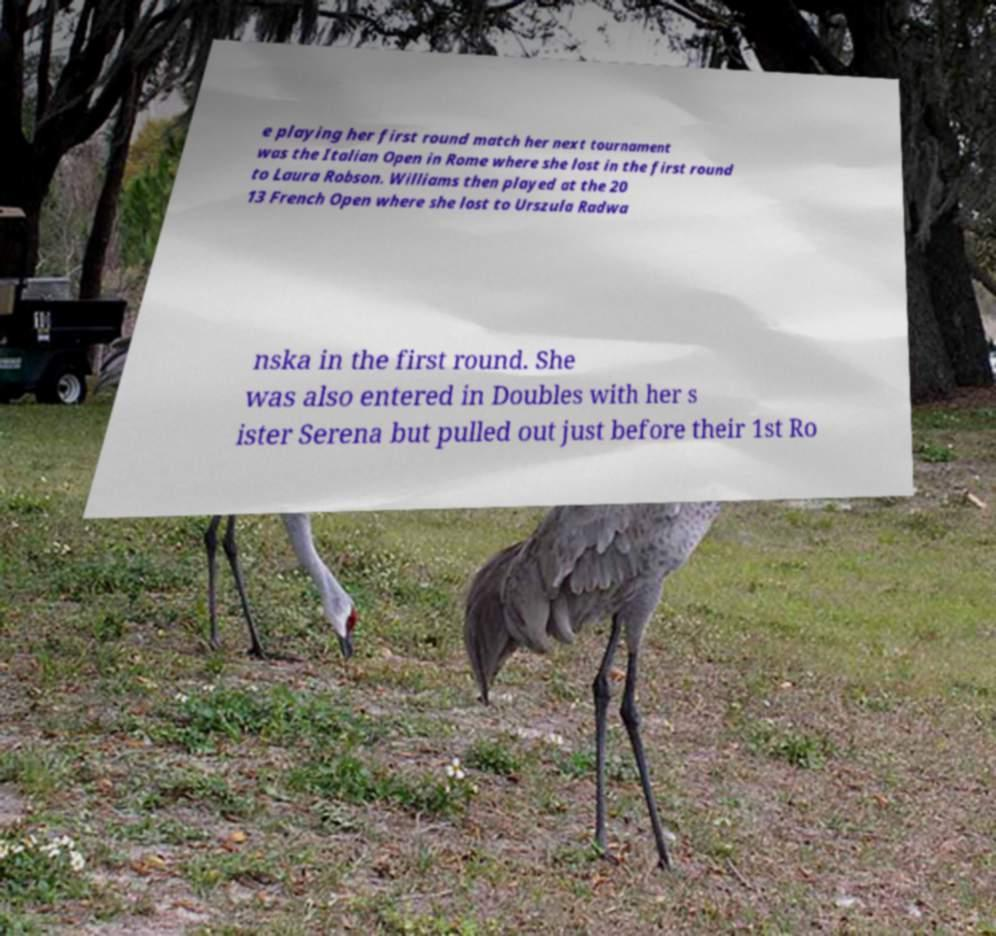What messages or text are displayed in this image? I need them in a readable, typed format. e playing her first round match her next tournament was the Italian Open in Rome where she lost in the first round to Laura Robson. Williams then played at the 20 13 French Open where she lost to Urszula Radwa nska in the first round. She was also entered in Doubles with her s ister Serena but pulled out just before their 1st Ro 